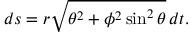<formula> <loc_0><loc_0><loc_500><loc_500>d s = r { \sqrt { \theta ^ { 2 } + \phi ^ { 2 } \sin ^ { 2 } \theta } } \, d t .</formula> 